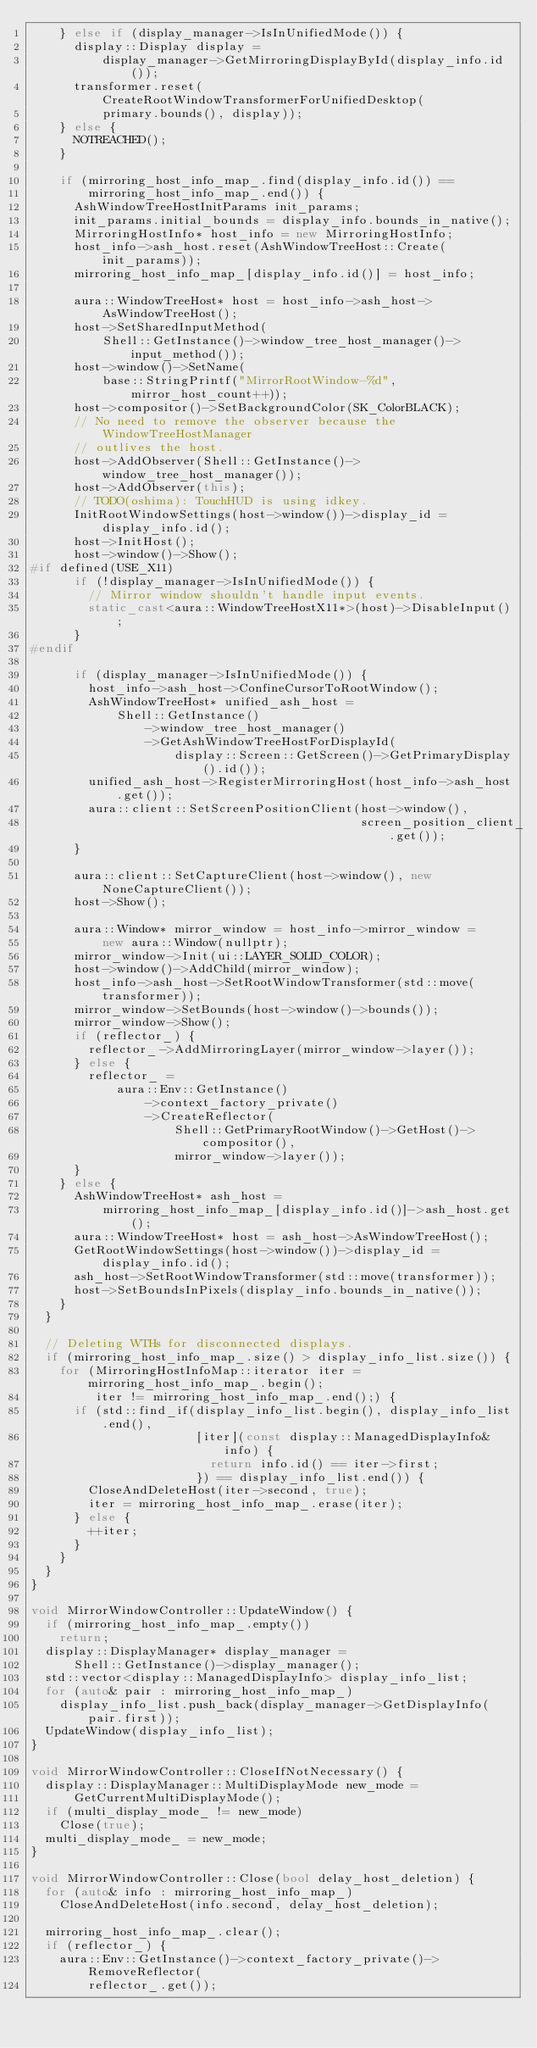<code> <loc_0><loc_0><loc_500><loc_500><_C++_>    } else if (display_manager->IsInUnifiedMode()) {
      display::Display display =
          display_manager->GetMirroringDisplayById(display_info.id());
      transformer.reset(CreateRootWindowTransformerForUnifiedDesktop(
          primary.bounds(), display));
    } else {
      NOTREACHED();
    }

    if (mirroring_host_info_map_.find(display_info.id()) ==
        mirroring_host_info_map_.end()) {
      AshWindowTreeHostInitParams init_params;
      init_params.initial_bounds = display_info.bounds_in_native();
      MirroringHostInfo* host_info = new MirroringHostInfo;
      host_info->ash_host.reset(AshWindowTreeHost::Create(init_params));
      mirroring_host_info_map_[display_info.id()] = host_info;

      aura::WindowTreeHost* host = host_info->ash_host->AsWindowTreeHost();
      host->SetSharedInputMethod(
          Shell::GetInstance()->window_tree_host_manager()->input_method());
      host->window()->SetName(
          base::StringPrintf("MirrorRootWindow-%d", mirror_host_count++));
      host->compositor()->SetBackgroundColor(SK_ColorBLACK);
      // No need to remove the observer because the WindowTreeHostManager
      // outlives the host.
      host->AddObserver(Shell::GetInstance()->window_tree_host_manager());
      host->AddObserver(this);
      // TODO(oshima): TouchHUD is using idkey.
      InitRootWindowSettings(host->window())->display_id = display_info.id();
      host->InitHost();
      host->window()->Show();
#if defined(USE_X11)
      if (!display_manager->IsInUnifiedMode()) {
        // Mirror window shouldn't handle input events.
        static_cast<aura::WindowTreeHostX11*>(host)->DisableInput();
      }
#endif

      if (display_manager->IsInUnifiedMode()) {
        host_info->ash_host->ConfineCursorToRootWindow();
        AshWindowTreeHost* unified_ash_host =
            Shell::GetInstance()
                ->window_tree_host_manager()
                ->GetAshWindowTreeHostForDisplayId(
                    display::Screen::GetScreen()->GetPrimaryDisplay().id());
        unified_ash_host->RegisterMirroringHost(host_info->ash_host.get());
        aura::client::SetScreenPositionClient(host->window(),
                                              screen_position_client_.get());
      }

      aura::client::SetCaptureClient(host->window(), new NoneCaptureClient());
      host->Show();

      aura::Window* mirror_window = host_info->mirror_window =
          new aura::Window(nullptr);
      mirror_window->Init(ui::LAYER_SOLID_COLOR);
      host->window()->AddChild(mirror_window);
      host_info->ash_host->SetRootWindowTransformer(std::move(transformer));
      mirror_window->SetBounds(host->window()->bounds());
      mirror_window->Show();
      if (reflector_) {
        reflector_->AddMirroringLayer(mirror_window->layer());
      } else {
        reflector_ =
            aura::Env::GetInstance()
                ->context_factory_private()
                ->CreateReflector(
                    Shell::GetPrimaryRootWindow()->GetHost()->compositor(),
                    mirror_window->layer());
      }
    } else {
      AshWindowTreeHost* ash_host =
          mirroring_host_info_map_[display_info.id()]->ash_host.get();
      aura::WindowTreeHost* host = ash_host->AsWindowTreeHost();
      GetRootWindowSettings(host->window())->display_id = display_info.id();
      ash_host->SetRootWindowTransformer(std::move(transformer));
      host->SetBoundsInPixels(display_info.bounds_in_native());
    }
  }

  // Deleting WTHs for disconnected displays.
  if (mirroring_host_info_map_.size() > display_info_list.size()) {
    for (MirroringHostInfoMap::iterator iter = mirroring_host_info_map_.begin();
         iter != mirroring_host_info_map_.end();) {
      if (std::find_if(display_info_list.begin(), display_info_list.end(),
                       [iter](const display::ManagedDisplayInfo& info) {
                         return info.id() == iter->first;
                       }) == display_info_list.end()) {
        CloseAndDeleteHost(iter->second, true);
        iter = mirroring_host_info_map_.erase(iter);
      } else {
        ++iter;
      }
    }
  }
}

void MirrorWindowController::UpdateWindow() {
  if (mirroring_host_info_map_.empty())
    return;
  display::DisplayManager* display_manager =
      Shell::GetInstance()->display_manager();
  std::vector<display::ManagedDisplayInfo> display_info_list;
  for (auto& pair : mirroring_host_info_map_)
    display_info_list.push_back(display_manager->GetDisplayInfo(pair.first));
  UpdateWindow(display_info_list);
}

void MirrorWindowController::CloseIfNotNecessary() {
  display::DisplayManager::MultiDisplayMode new_mode =
      GetCurrentMultiDisplayMode();
  if (multi_display_mode_ != new_mode)
    Close(true);
  multi_display_mode_ = new_mode;
}

void MirrorWindowController::Close(bool delay_host_deletion) {
  for (auto& info : mirroring_host_info_map_)
    CloseAndDeleteHost(info.second, delay_host_deletion);

  mirroring_host_info_map_.clear();
  if (reflector_) {
    aura::Env::GetInstance()->context_factory_private()->RemoveReflector(
        reflector_.get());</code> 